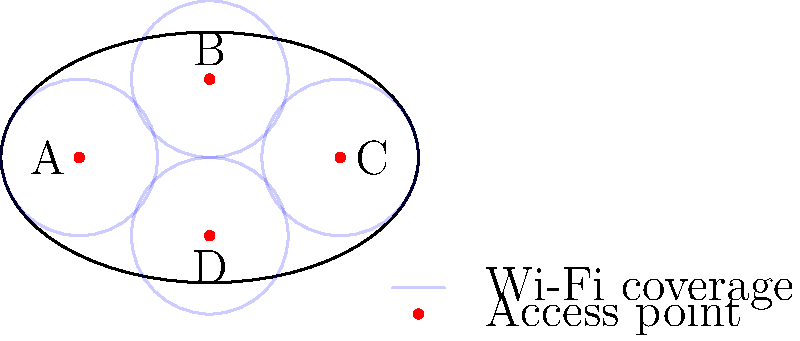In optimizing the Wi-Fi network topology for your football stadium, you've placed four access points (A, B, C, and D) as shown in the diagram. Each access point has a circular coverage area. To maximize coverage and minimize interference, which access point should be upgraded to increase its range by 25% to cover a potential dead zone near the stadium's edge? To determine which access point should be upgraded, we need to analyze the coverage and potential dead zones in the stadium:

1. Observe the current coverage:
   - Four access points (A, B, C, and D) are placed symmetrically in the stadium.
   - Each access point has a circular coverage area.

2. Identify potential dead zones:
   - The corners of the elliptical stadium are the most likely areas for dead zones.
   - These areas are furthest from the centrally placed access points.

3. Evaluate each access point:
   - A and C: Located on the long axis of the stadium, providing good coverage along the sides.
   - B and D: Located on the short axis, covering the top and bottom areas.

4. Consider the stadium's shape:
   - The elliptical shape means the corners along the long axis are further from the center than those along the short axis.

5. Identify the best candidate for upgrade:
   - Access points A or C are better positioned to cover corner dead zones if upgraded.
   - Upgrading either A or C would extend coverage to the furthest corners of the stadium.

6. Choose between A and C:
   - Both are equivalent due to symmetry.
   - Arbitrarily select A for the upgrade.

7. Calculate the upgrade effect:
   - Current range: $r$
   - Upgraded range: $r * 1.25 = 1.25r$
   - This 25% increase will extend coverage to the corner dead zone.

Therefore, upgrading access point A (or C) by 25% will most effectively cover the potential dead zone near the stadium's edge.
Answer: A 